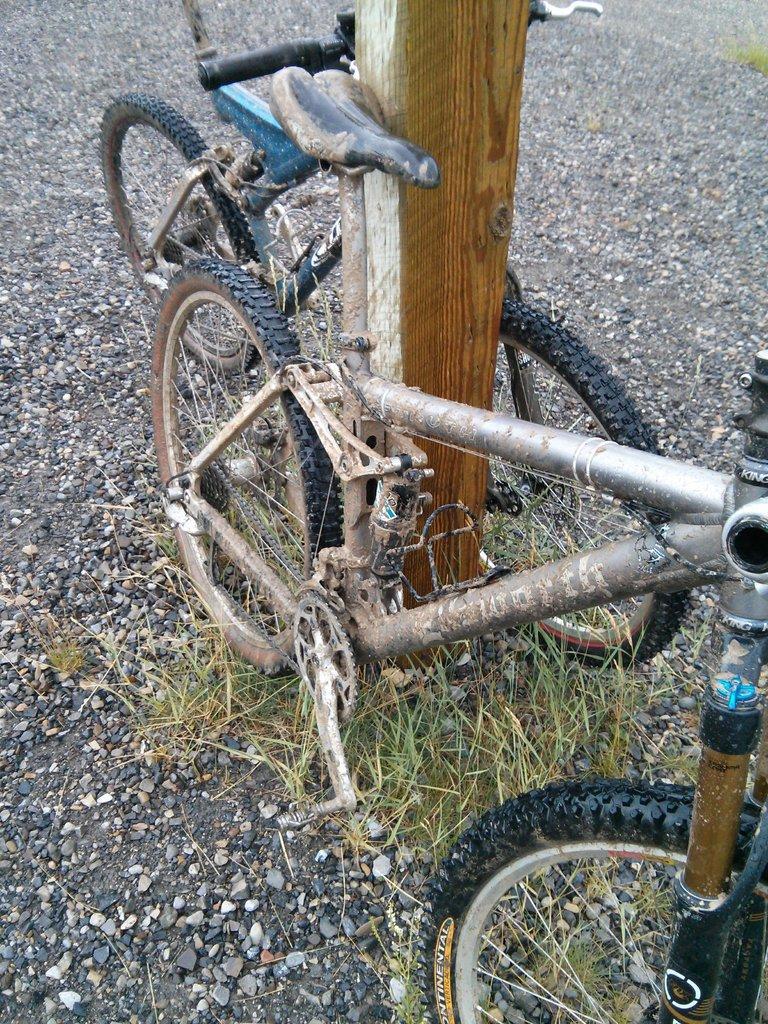Could you give a brief overview of what you see in this image? This image is taken outdoors. At the bottom of the image there is a ground with a few pebbles on it. In the middle of the image there is a wooden pole and two bicycles are parked on the ground. 